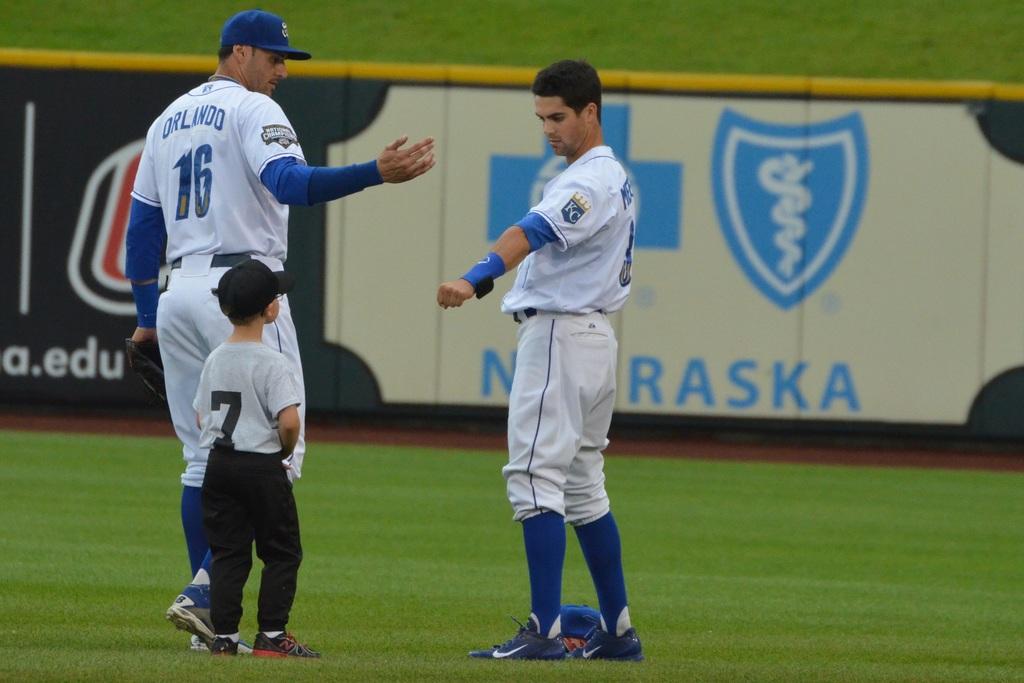What state is this game held in?
Your answer should be compact. Nebraska. What is the name of the player with jersey number 16?
Your answer should be compact. Orlando. 